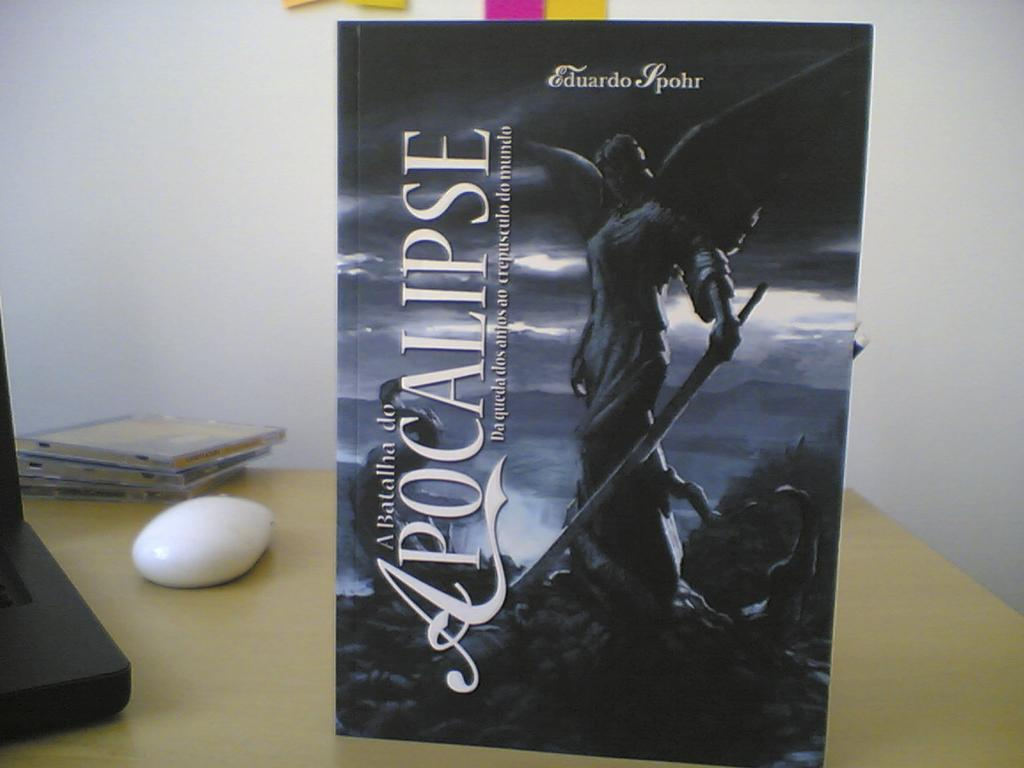<image>
Share a concise interpretation of the image provided. A sign on a table for Apocalipse featuring an angle statue. 